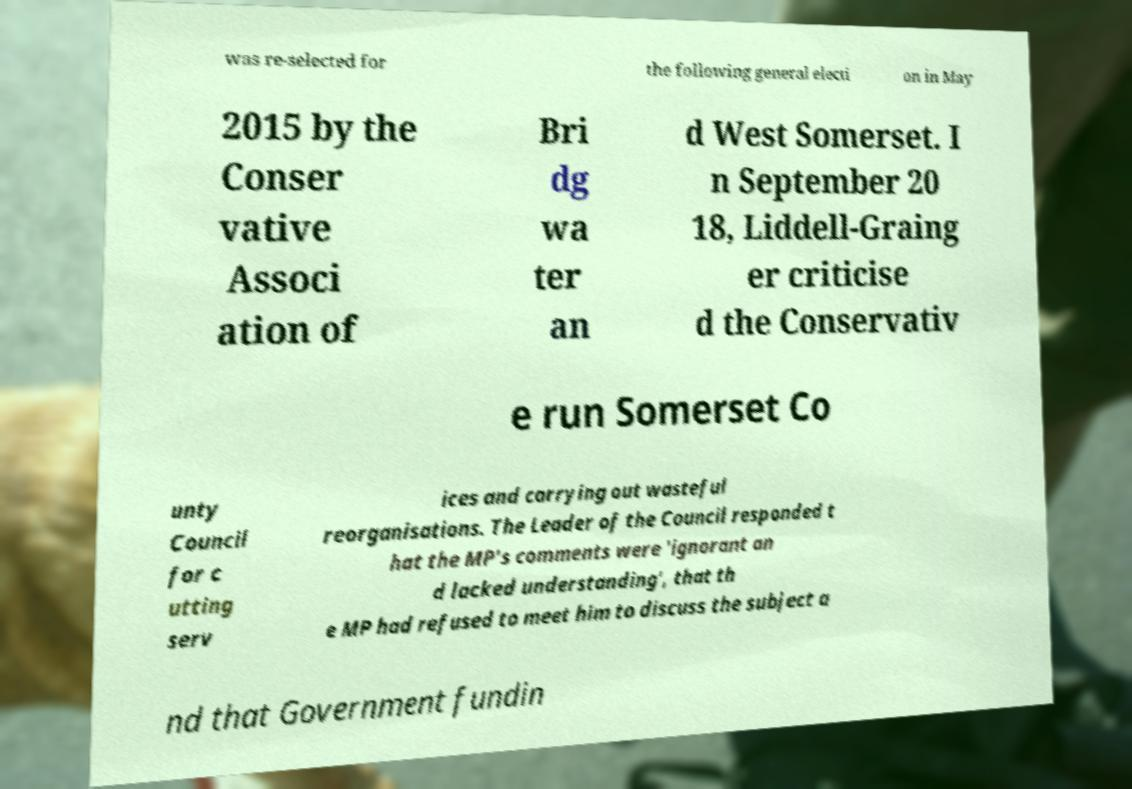For documentation purposes, I need the text within this image transcribed. Could you provide that? was re-selected for the following general electi on in May 2015 by the Conser vative Associ ation of Bri dg wa ter an d West Somerset. I n September 20 18, Liddell-Graing er criticise d the Conservativ e run Somerset Co unty Council for c utting serv ices and carrying out wasteful reorganisations. The Leader of the Council responded t hat the MP's comments were 'ignorant an d lacked understanding', that th e MP had refused to meet him to discuss the subject a nd that Government fundin 